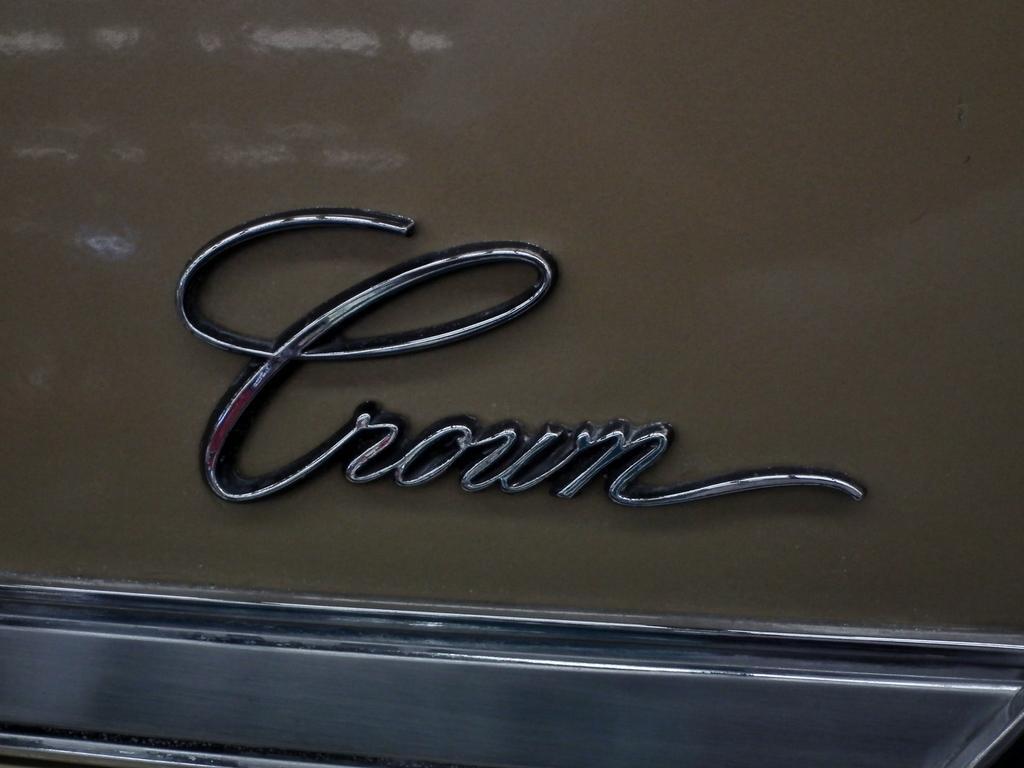How would you summarize this image in a sentence or two? In this image we can see an object which looks like a part of a vehicle and we can see a text on the vehicle. 